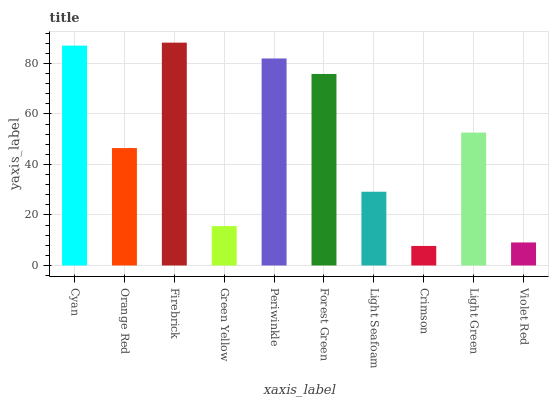Is Crimson the minimum?
Answer yes or no. Yes. Is Firebrick the maximum?
Answer yes or no. Yes. Is Orange Red the minimum?
Answer yes or no. No. Is Orange Red the maximum?
Answer yes or no. No. Is Cyan greater than Orange Red?
Answer yes or no. Yes. Is Orange Red less than Cyan?
Answer yes or no. Yes. Is Orange Red greater than Cyan?
Answer yes or no. No. Is Cyan less than Orange Red?
Answer yes or no. No. Is Light Green the high median?
Answer yes or no. Yes. Is Orange Red the low median?
Answer yes or no. Yes. Is Forest Green the high median?
Answer yes or no. No. Is Green Yellow the low median?
Answer yes or no. No. 